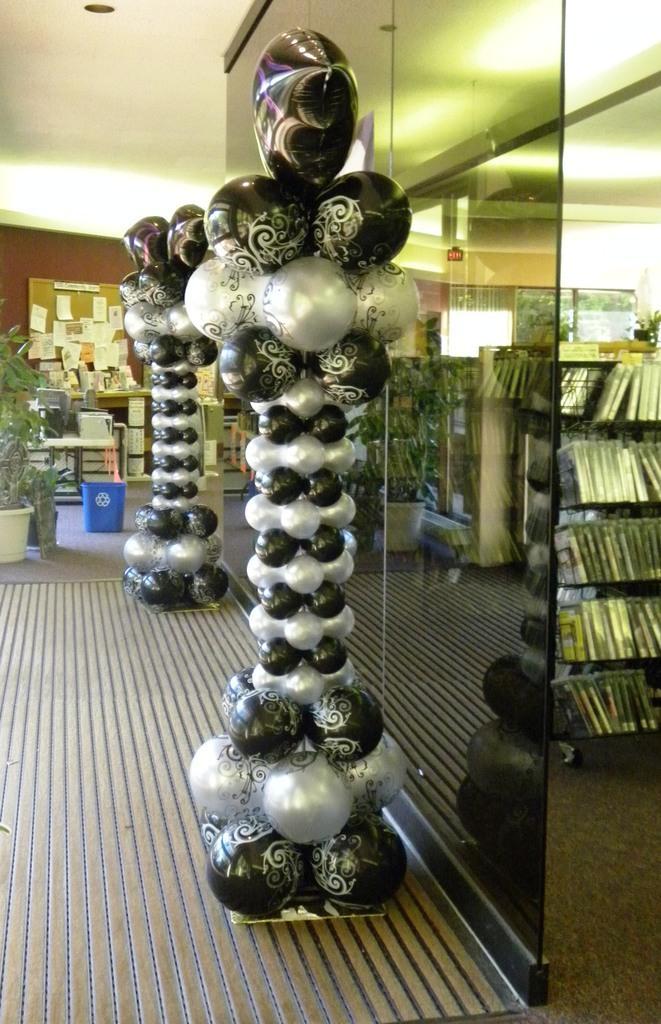Could you give a brief overview of what you see in this image? In this picture I can see the balloon arch with stand. I can see glass wall. I can see the plant pot on the left side. I can see a number of books on the rack. 